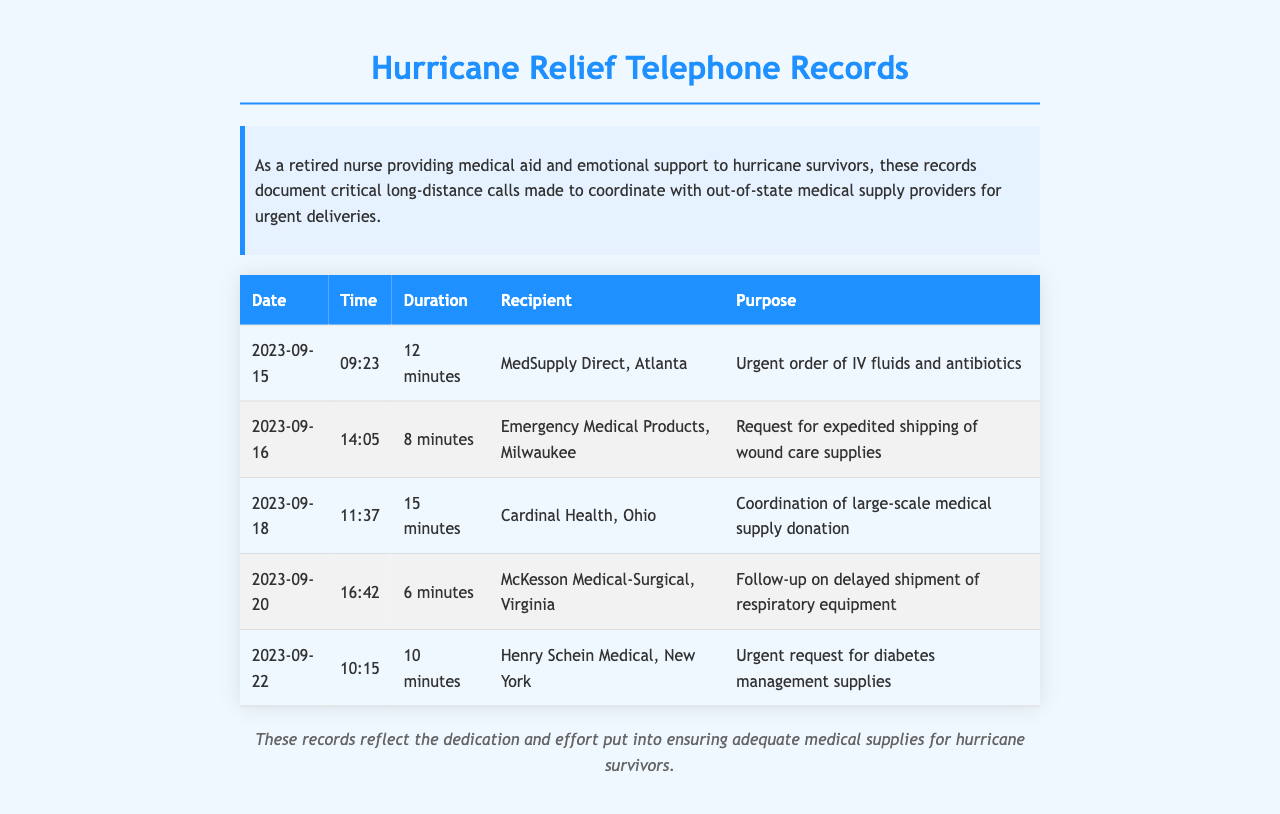What was the date of the call to MedSupply Direct? The document lists the date of the call to MedSupply Direct as September 15, 2023.
Answer: September 15, 2023 How long was the call to Emergency Medical Products? According to the document, the duration of the call to Emergency Medical Products was 8 minutes.
Answer: 8 minutes What was the purpose of the call made on September 20? The purpose of the call on September 20 was a follow-up on delayed shipment of respiratory equipment.
Answer: Follow-up on delayed shipment of respiratory equipment Which company was contacted for diabetes management supplies? The document states that Henry Schein Medical from New York was contacted for diabetes management supplies.
Answer: Henry Schein Medical, New York Which call had the longest duration? The call that lasted the longest in duration was the one to Cardinal Health on September 18, which lasted 15 minutes.
Answer: 15 minutes How many minutes was the call to McKesson Medical-Surgical? The duration of the call to McKesson Medical-Surgical was 6 minutes.
Answer: 6 minutes What type of records are documented here? The records documented here are telephone records related to hurricane relief.
Answer: Telephone records What was the total number of calls listed? The document lists a total of five calls made for coordination with medical supply providers.
Answer: Five calls What was the purpose of the call to Cardinal Health? The call to Cardinal Health was for coordination of large-scale medical supply donation.
Answer: Coordination of large-scale medical supply donation 